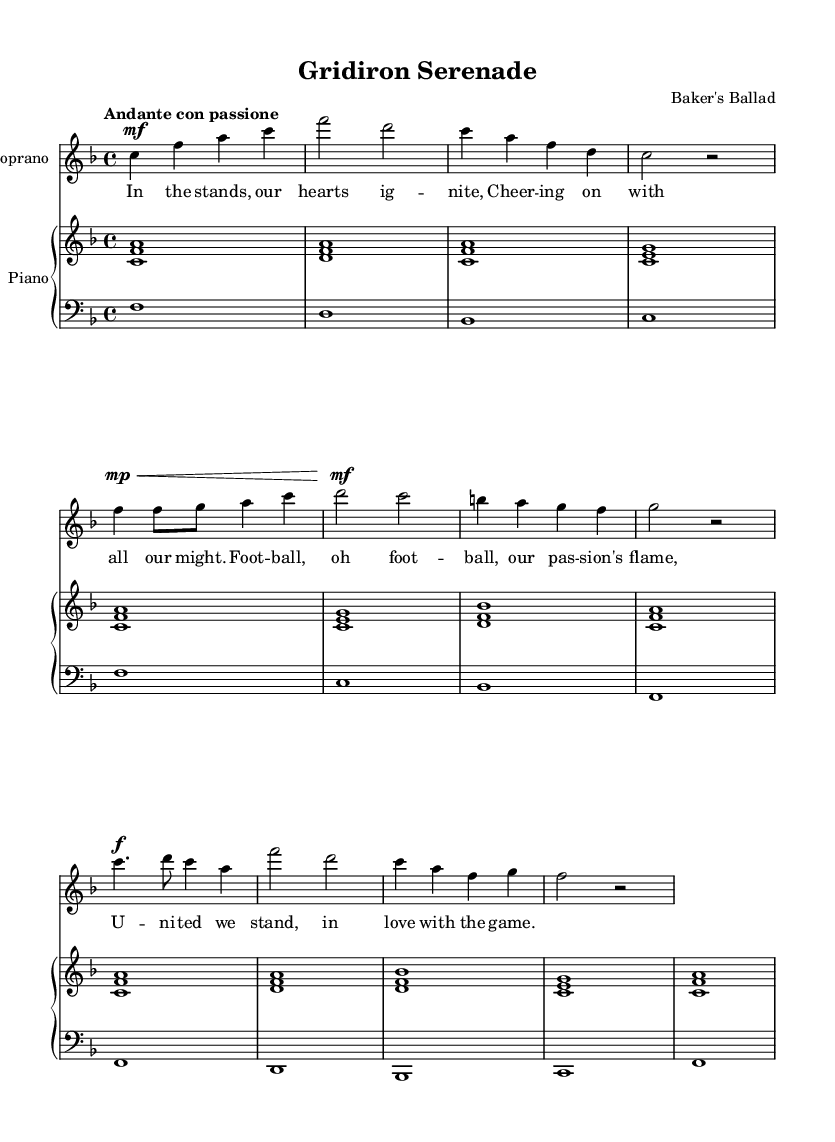What is the title of this piece? The title "Gridiron Serenade" is stated in the header section of the sheet music.
Answer: Gridiron Serenade What is the key signature of this music? The key signature is F major, indicated by the presence of one flat (B flat) in the key signature portion at the beginning of the staff.
Answer: F major What is the time signature of this music? The time signature is 4/4, which can be found right after the key signature at the beginning of the staff, indicating four beats per measure.
Answer: 4/4 What is the tempo marking for this piece? The tempo marking "Andante con passione" is written above the staff, indicating the speed and character of the music.
Answer: Andante con passione How many measures are in the introduction? The introduction has four measures, as counted from the start to the end of the section designated as the introduction.
Answer: 4 What is the dynamic marking for the chorus? The dynamic marking for the chorus is forte, denoted by the "f" symbol preceding the note values in the chorus section.
Answer: forte What thematic element does the opera explore? The opera explores the passion of dedicated fans and their love for the game, as expressed in the lyrics and music.
Answer: Passion for football 